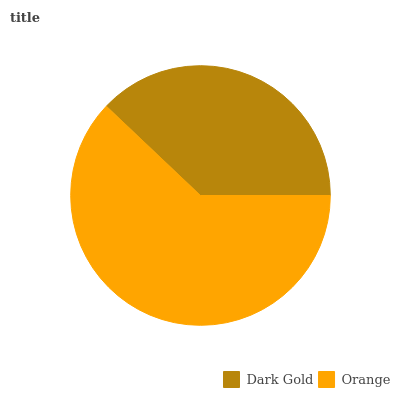Is Dark Gold the minimum?
Answer yes or no. Yes. Is Orange the maximum?
Answer yes or no. Yes. Is Orange the minimum?
Answer yes or no. No. Is Orange greater than Dark Gold?
Answer yes or no. Yes. Is Dark Gold less than Orange?
Answer yes or no. Yes. Is Dark Gold greater than Orange?
Answer yes or no. No. Is Orange less than Dark Gold?
Answer yes or no. No. Is Orange the high median?
Answer yes or no. Yes. Is Dark Gold the low median?
Answer yes or no. Yes. Is Dark Gold the high median?
Answer yes or no. No. Is Orange the low median?
Answer yes or no. No. 